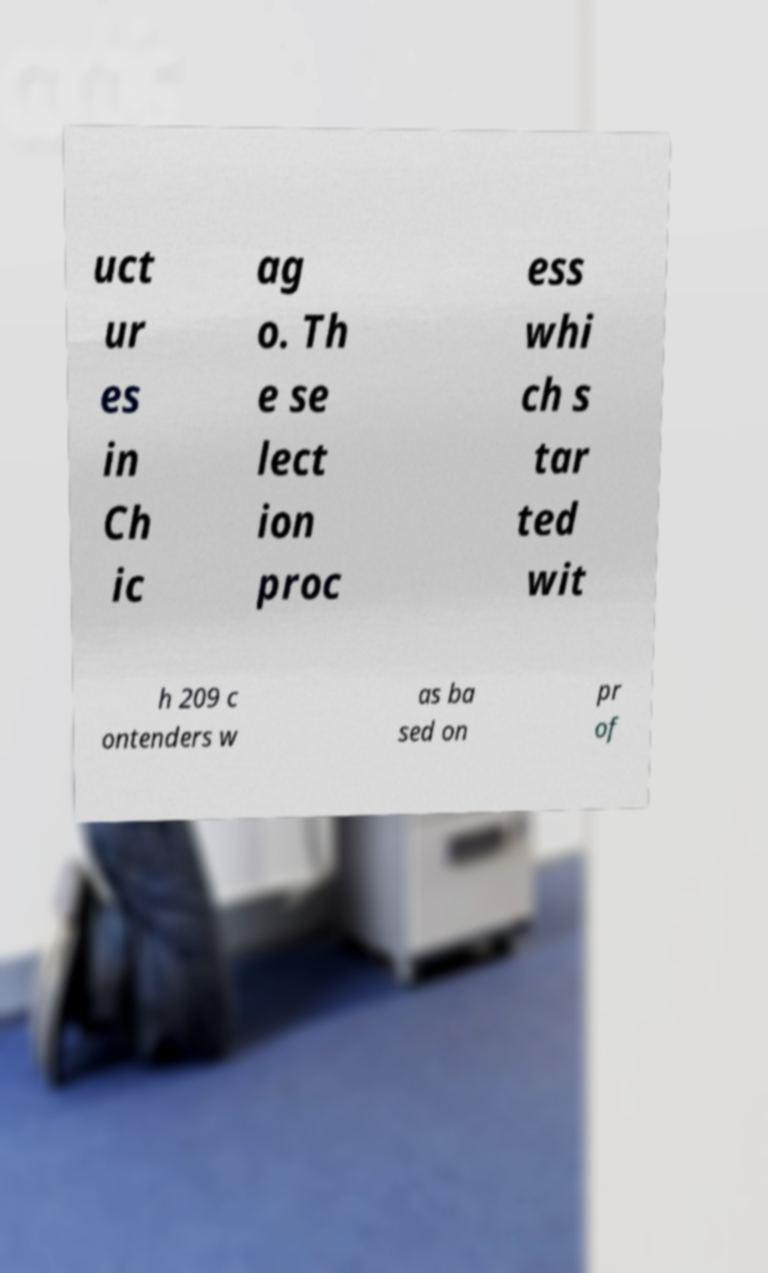Can you read and provide the text displayed in the image?This photo seems to have some interesting text. Can you extract and type it out for me? uct ur es in Ch ic ag o. Th e se lect ion proc ess whi ch s tar ted wit h 209 c ontenders w as ba sed on pr of 